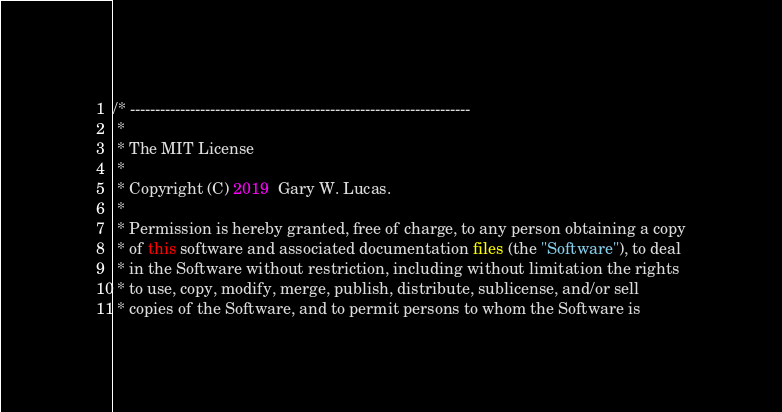<code> <loc_0><loc_0><loc_500><loc_500><_Java_>/* --------------------------------------------------------------------
 *
 * The MIT License
 *
 * Copyright (C) 2019  Gary W. Lucas.
 *
 * Permission is hereby granted, free of charge, to any person obtaining a copy
 * of this software and associated documentation files (the "Software"), to deal
 * in the Software without restriction, including without limitation the rights
 * to use, copy, modify, merge, publish, distribute, sublicense, and/or sell
 * copies of the Software, and to permit persons to whom the Software is</code> 